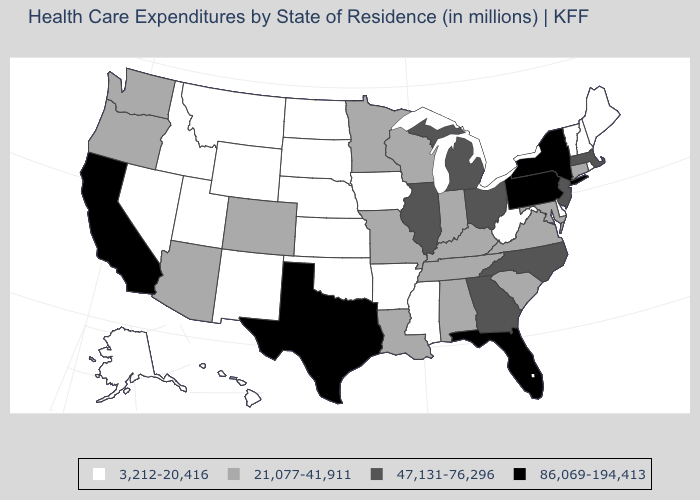What is the value of Massachusetts?
Short answer required. 47,131-76,296. Which states have the highest value in the USA?
Quick response, please. California, Florida, New York, Pennsylvania, Texas. What is the lowest value in the USA?
Be succinct. 3,212-20,416. What is the value of Colorado?
Keep it brief. 21,077-41,911. What is the lowest value in the Northeast?
Give a very brief answer. 3,212-20,416. Is the legend a continuous bar?
Quick response, please. No. Among the states that border Nevada , does Idaho have the lowest value?
Give a very brief answer. Yes. Name the states that have a value in the range 86,069-194,413?
Write a very short answer. California, Florida, New York, Pennsylvania, Texas. Does Texas have a higher value than Tennessee?
Keep it brief. Yes. Which states have the lowest value in the USA?
Concise answer only. Alaska, Arkansas, Delaware, Hawaii, Idaho, Iowa, Kansas, Maine, Mississippi, Montana, Nebraska, Nevada, New Hampshire, New Mexico, North Dakota, Oklahoma, Rhode Island, South Dakota, Utah, Vermont, West Virginia, Wyoming. Which states have the lowest value in the South?
Quick response, please. Arkansas, Delaware, Mississippi, Oklahoma, West Virginia. Does Vermont have the lowest value in the USA?
Answer briefly. Yes. Does Arkansas have the lowest value in the USA?
Keep it brief. Yes. Is the legend a continuous bar?
Write a very short answer. No. 